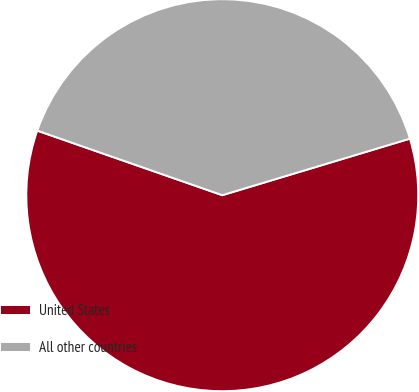Convert chart. <chart><loc_0><loc_0><loc_500><loc_500><pie_chart><fcel>United States<fcel>All other countries<nl><fcel>60.0%<fcel>40.0%<nl></chart> 